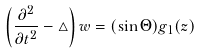<formula> <loc_0><loc_0><loc_500><loc_500>\left ( \frac { \partial ^ { 2 } } { \partial t ^ { 2 } } - \triangle \right ) w = ( \sin \Theta ) g _ { 1 } ( z )</formula> 